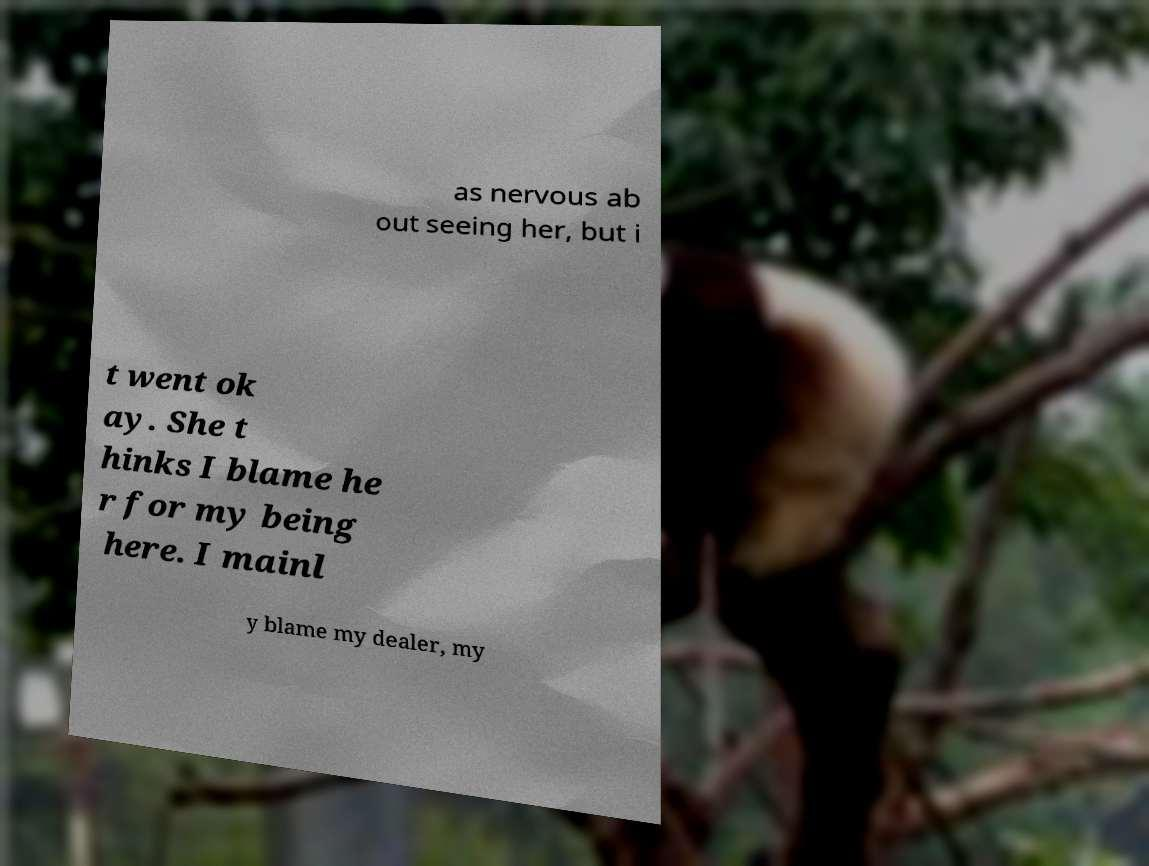Please read and relay the text visible in this image. What does it say? as nervous ab out seeing her, but i t went ok ay. She t hinks I blame he r for my being here. I mainl y blame my dealer, my 